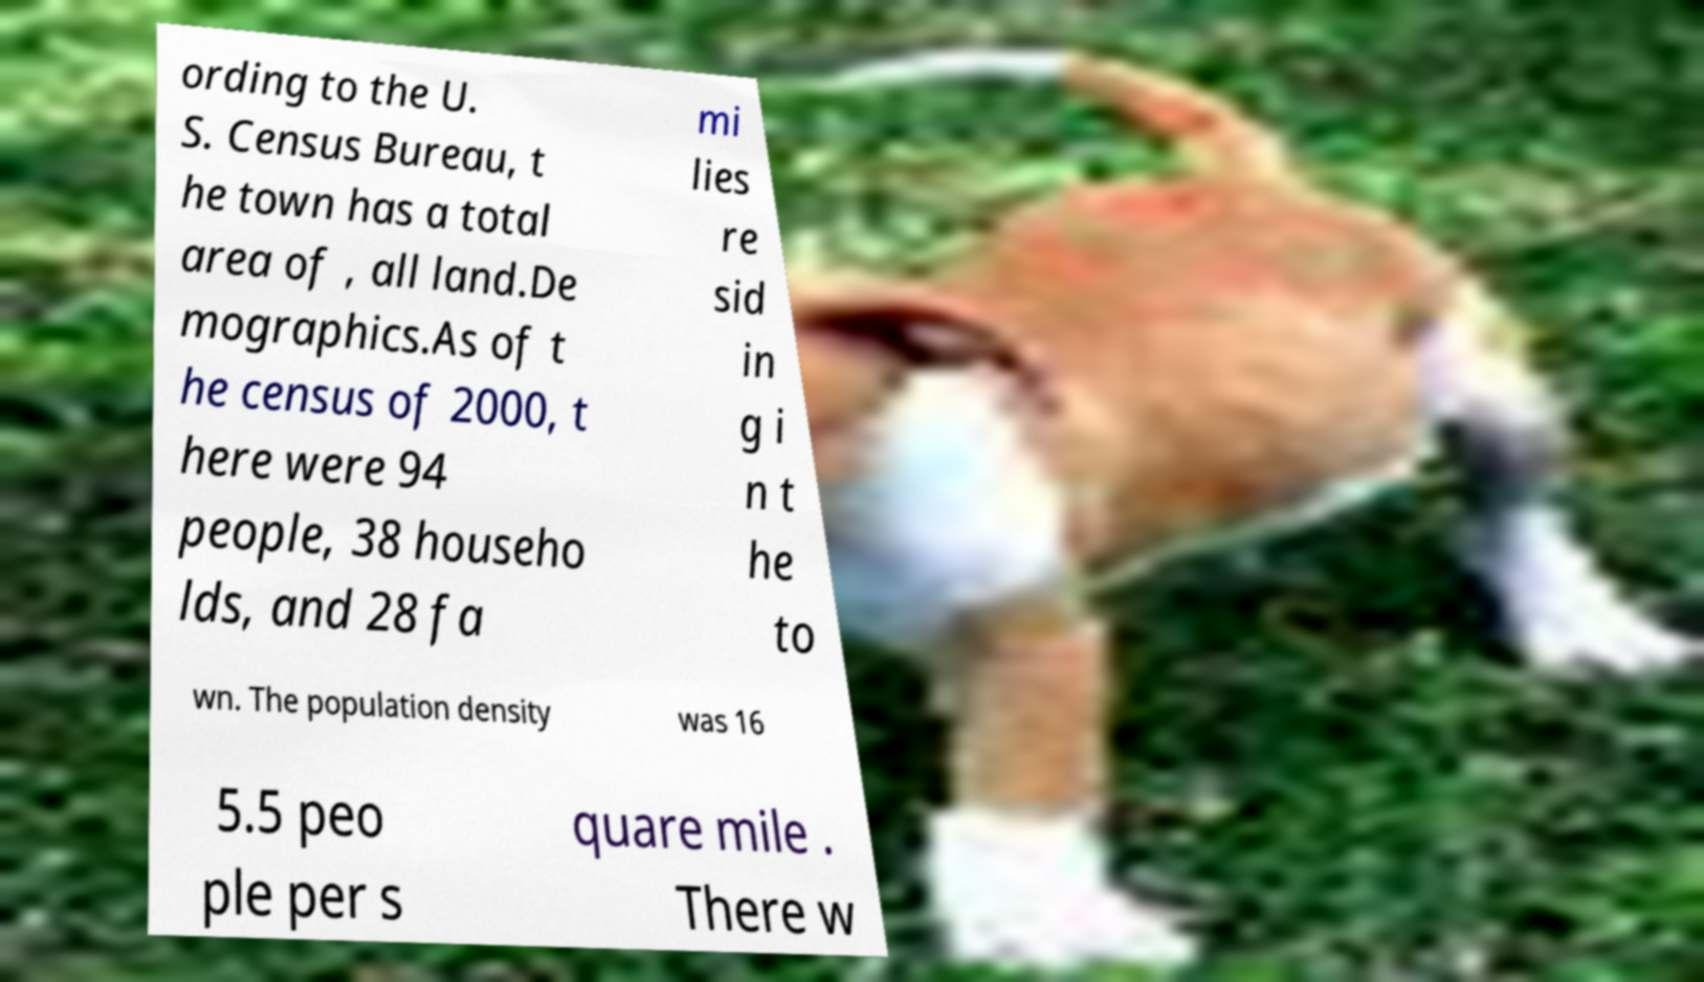Please identify and transcribe the text found in this image. ording to the U. S. Census Bureau, t he town has a total area of , all land.De mographics.As of t he census of 2000, t here were 94 people, 38 househo lds, and 28 fa mi lies re sid in g i n t he to wn. The population density was 16 5.5 peo ple per s quare mile . There w 